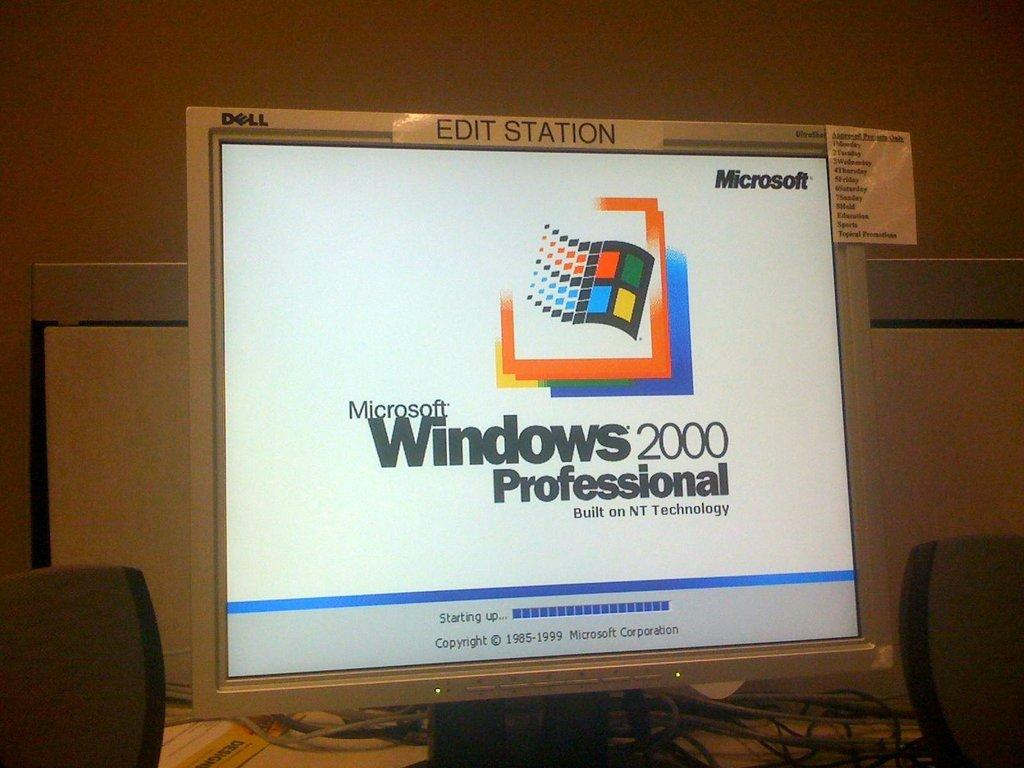<image>
Render a clear and concise summary of the photo. A computer monitor with Microsoft Windows 2000 Professional edition start up screen. 